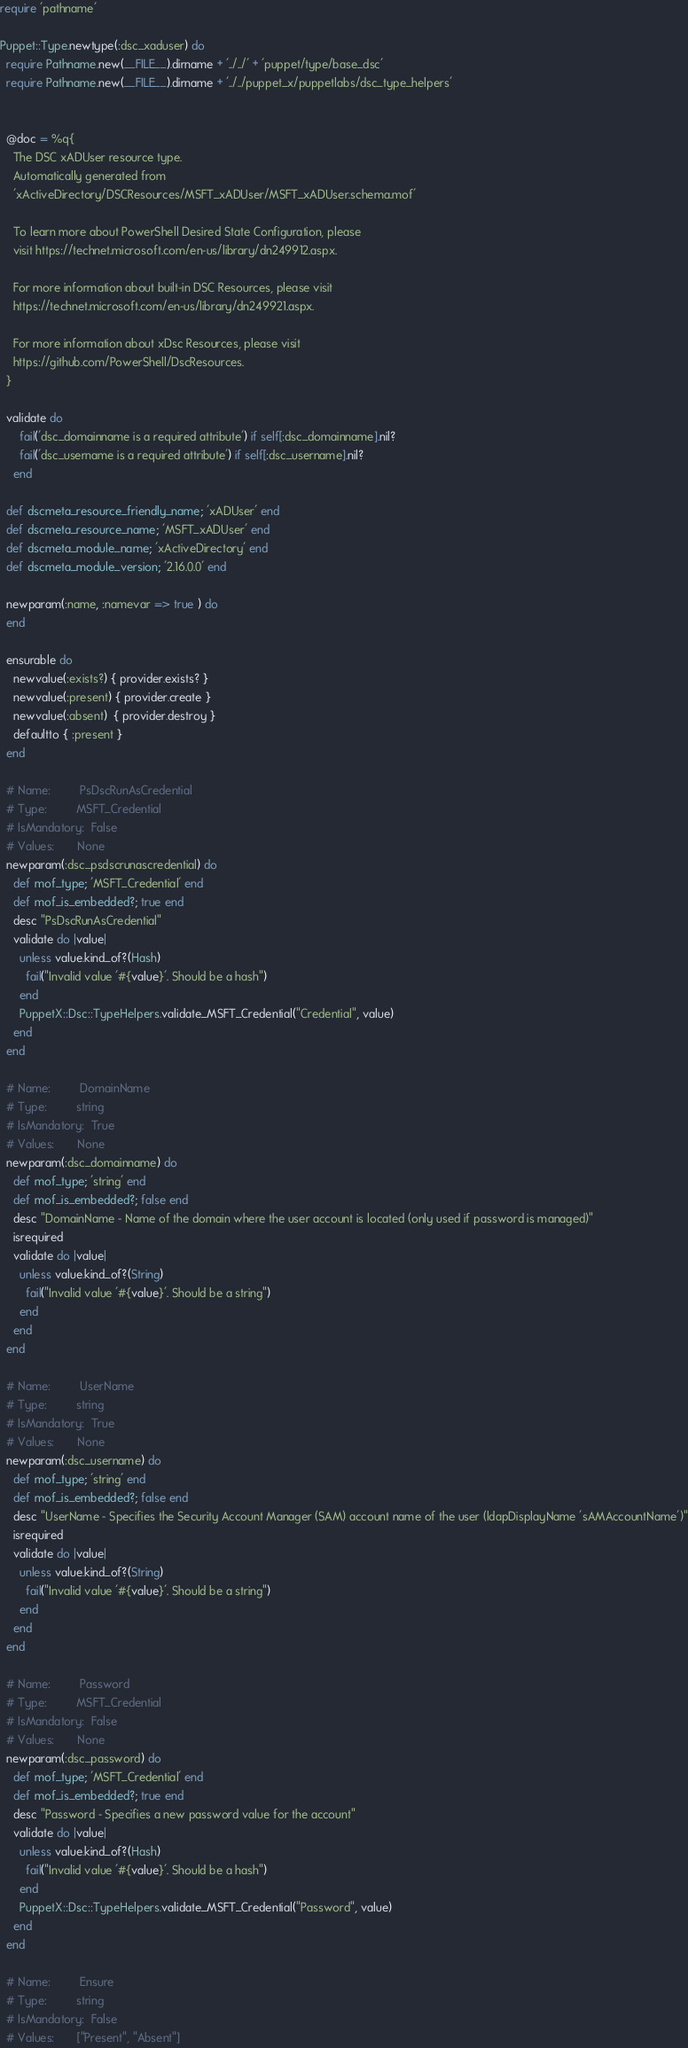Convert code to text. <code><loc_0><loc_0><loc_500><loc_500><_Ruby_>require 'pathname'

Puppet::Type.newtype(:dsc_xaduser) do
  require Pathname.new(__FILE__).dirname + '../../' + 'puppet/type/base_dsc'
  require Pathname.new(__FILE__).dirname + '../../puppet_x/puppetlabs/dsc_type_helpers'


  @doc = %q{
    The DSC xADUser resource type.
    Automatically generated from
    'xActiveDirectory/DSCResources/MSFT_xADUser/MSFT_xADUser.schema.mof'

    To learn more about PowerShell Desired State Configuration, please
    visit https://technet.microsoft.com/en-us/library/dn249912.aspx.

    For more information about built-in DSC Resources, please visit
    https://technet.microsoft.com/en-us/library/dn249921.aspx.

    For more information about xDsc Resources, please visit
    https://github.com/PowerShell/DscResources.
  }

  validate do
      fail('dsc_domainname is a required attribute') if self[:dsc_domainname].nil?
      fail('dsc_username is a required attribute') if self[:dsc_username].nil?
    end

  def dscmeta_resource_friendly_name; 'xADUser' end
  def dscmeta_resource_name; 'MSFT_xADUser' end
  def dscmeta_module_name; 'xActiveDirectory' end
  def dscmeta_module_version; '2.16.0.0' end

  newparam(:name, :namevar => true ) do
  end

  ensurable do
    newvalue(:exists?) { provider.exists? }
    newvalue(:present) { provider.create }
    newvalue(:absent)  { provider.destroy }
    defaultto { :present }
  end

  # Name:         PsDscRunAsCredential
  # Type:         MSFT_Credential
  # IsMandatory:  False
  # Values:       None
  newparam(:dsc_psdscrunascredential) do
    def mof_type; 'MSFT_Credential' end
    def mof_is_embedded?; true end
    desc "PsDscRunAsCredential"
    validate do |value|
      unless value.kind_of?(Hash)
        fail("Invalid value '#{value}'. Should be a hash")
      end
      PuppetX::Dsc::TypeHelpers.validate_MSFT_Credential("Credential", value)
    end
  end

  # Name:         DomainName
  # Type:         string
  # IsMandatory:  True
  # Values:       None
  newparam(:dsc_domainname) do
    def mof_type; 'string' end
    def mof_is_embedded?; false end
    desc "DomainName - Name of the domain where the user account is located (only used if password is managed)"
    isrequired
    validate do |value|
      unless value.kind_of?(String)
        fail("Invalid value '#{value}'. Should be a string")
      end
    end
  end

  # Name:         UserName
  # Type:         string
  # IsMandatory:  True
  # Values:       None
  newparam(:dsc_username) do
    def mof_type; 'string' end
    def mof_is_embedded?; false end
    desc "UserName - Specifies the Security Account Manager (SAM) account name of the user (ldapDisplayName 'sAMAccountName')"
    isrequired
    validate do |value|
      unless value.kind_of?(String)
        fail("Invalid value '#{value}'. Should be a string")
      end
    end
  end

  # Name:         Password
  # Type:         MSFT_Credential
  # IsMandatory:  False
  # Values:       None
  newparam(:dsc_password) do
    def mof_type; 'MSFT_Credential' end
    def mof_is_embedded?; true end
    desc "Password - Specifies a new password value for the account"
    validate do |value|
      unless value.kind_of?(Hash)
        fail("Invalid value '#{value}'. Should be a hash")
      end
      PuppetX::Dsc::TypeHelpers.validate_MSFT_Credential("Password", value)
    end
  end

  # Name:         Ensure
  # Type:         string
  # IsMandatory:  False
  # Values:       ["Present", "Absent"]</code> 